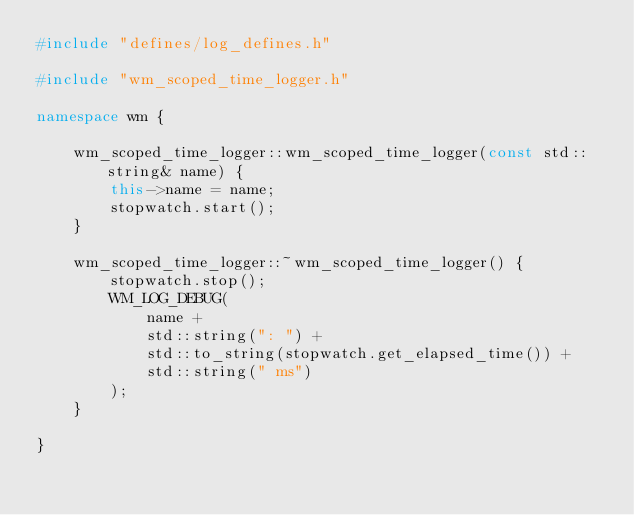<code> <loc_0><loc_0><loc_500><loc_500><_C++_>#include "defines/log_defines.h"

#include "wm_scoped_time_logger.h"

namespace wm {

	wm_scoped_time_logger::wm_scoped_time_logger(const std::string& name) {
		this->name = name;
		stopwatch.start();
	}

	wm_scoped_time_logger::~wm_scoped_time_logger() {
		stopwatch.stop();
		WM_LOG_DEBUG(
			name +
			std::string(": ") +
			std::to_string(stopwatch.get_elapsed_time()) +
			std::string(" ms")
		);
	}

}
</code> 